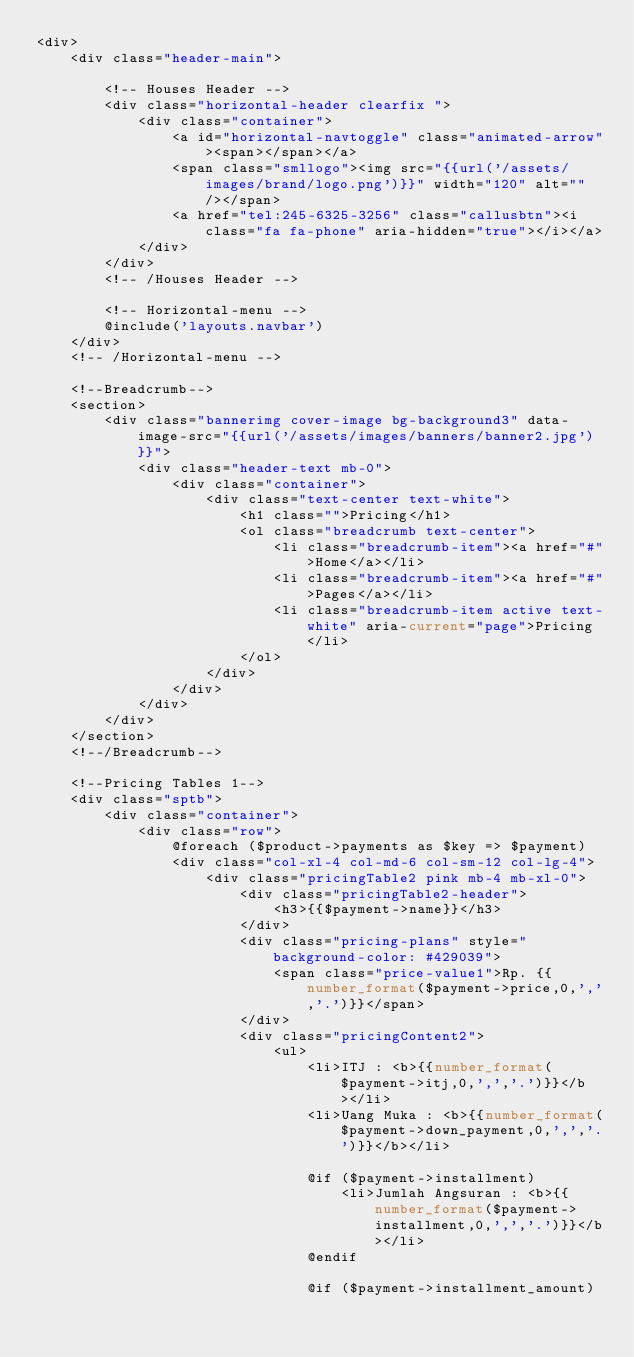Convert code to text. <code><loc_0><loc_0><loc_500><loc_500><_PHP_><div>
    <div class="header-main">

        <!-- Houses Header -->
        <div class="horizontal-header clearfix ">
            <div class="container">
                <a id="horizontal-navtoggle" class="animated-arrow"><span></span></a>
                <span class="smllogo"><img src="{{url('/assets/images/brand/logo.png')}}" width="120" alt="" /></span>
                <a href="tel:245-6325-3256" class="callusbtn"><i class="fa fa-phone" aria-hidden="true"></i></a>
            </div>
        </div>
        <!-- /Houses Header -->

        <!-- Horizontal-menu -->
        @include('layouts.navbar')
    </div>
    <!-- /Horizontal-menu -->

    <!--Breadcrumb-->
    <section>
        <div class="bannerimg cover-image bg-background3" data-image-src="{{url('/assets/images/banners/banner2.jpg')}}">
            <div class="header-text mb-0">
                <div class="container">
                    <div class="text-center text-white">
                        <h1 class="">Pricing</h1>
                        <ol class="breadcrumb text-center">
                            <li class="breadcrumb-item"><a href="#">Home</a></li>
                            <li class="breadcrumb-item"><a href="#">Pages</a></li>
                            <li class="breadcrumb-item active text-white" aria-current="page">Pricing</li>
                        </ol>
                    </div>
                </div>
            </div>
        </div>
    </section>
    <!--/Breadcrumb-->

    <!--Pricing Tables 1-->
    <div class="sptb">
        <div class="container">
            <div class="row">
                @foreach ($product->payments as $key => $payment)
                <div class="col-xl-4 col-md-6 col-sm-12 col-lg-4">
                    <div class="pricingTable2 pink mb-4 mb-xl-0">
                        <div class="pricingTable2-header">
                            <h3>{{$payment->name}}</h3>
                        </div>
                        <div class="pricing-plans" style="background-color: #429039">
                            <span class="price-value1">Rp. {{number_format($payment->price,0,',','.')}}</span>
                        </div>
                        <div class="pricingContent2">
                            <ul>
                                <li>ITJ : <b>{{number_format($payment->itj,0,',','.')}}</b></li>
                                <li>Uang Muka : <b>{{number_format($payment->down_payment,0,',','.')}}</b></li>

                                @if ($payment->installment)
                                    <li>Jumlah Angsuran : <b>{{number_format($payment->installment,0,',','.')}}</b></li>
                                @endif

                                @if ($payment->installment_amount)</code> 